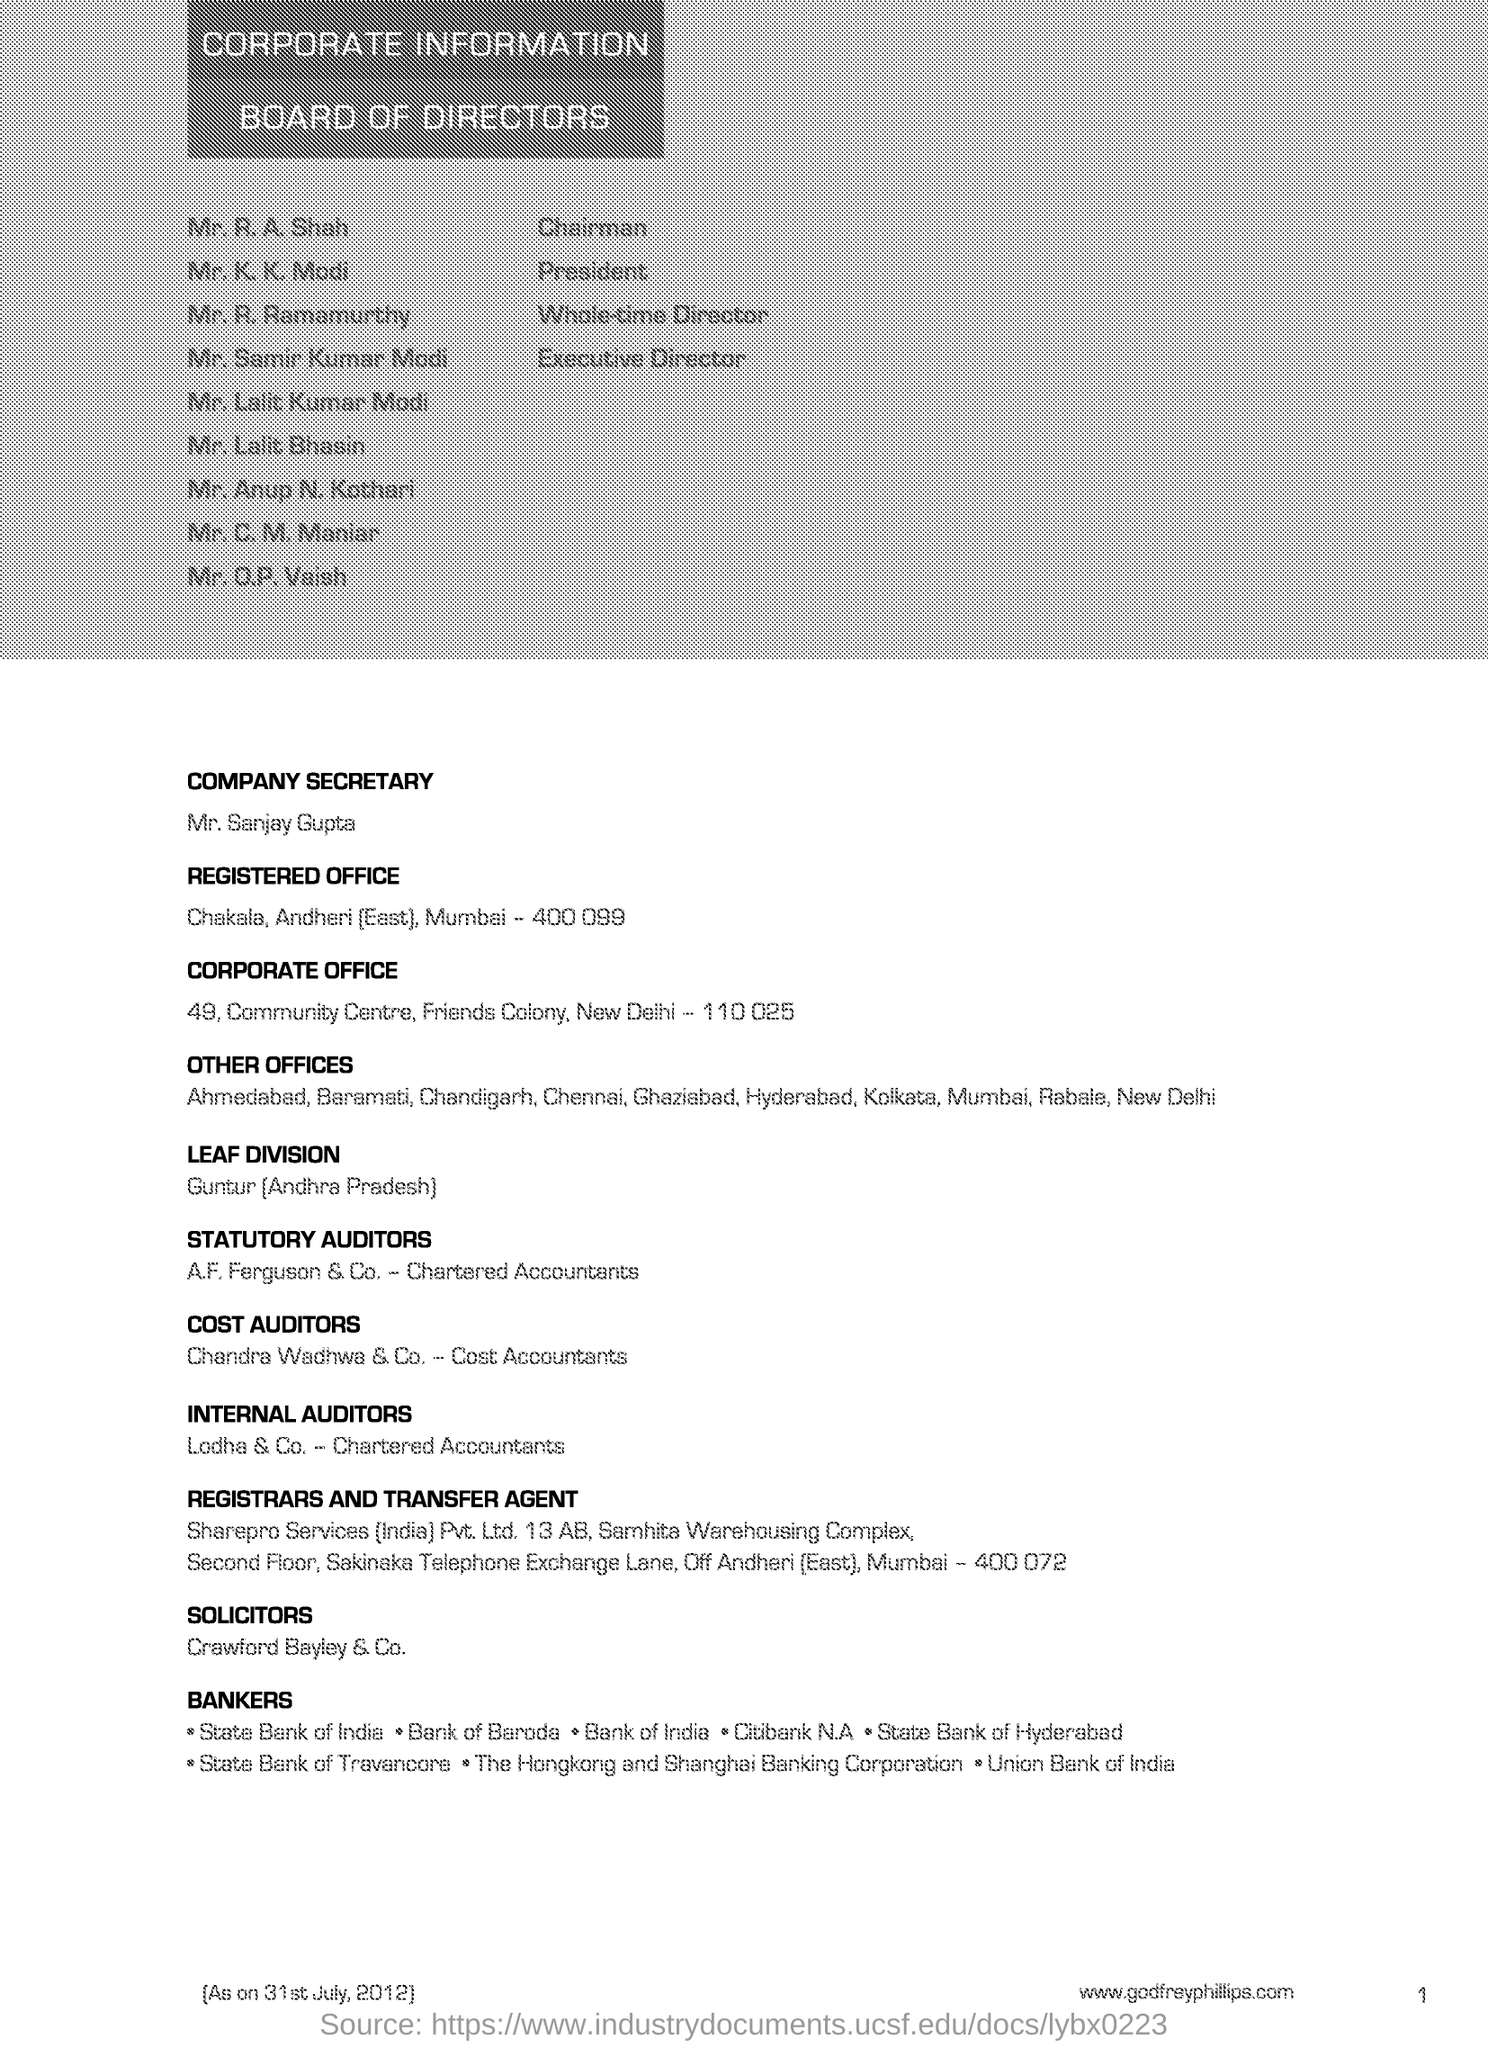Leaf division is situated at which place?
Make the answer very short. Guntur [Andhra Pradesh]. 